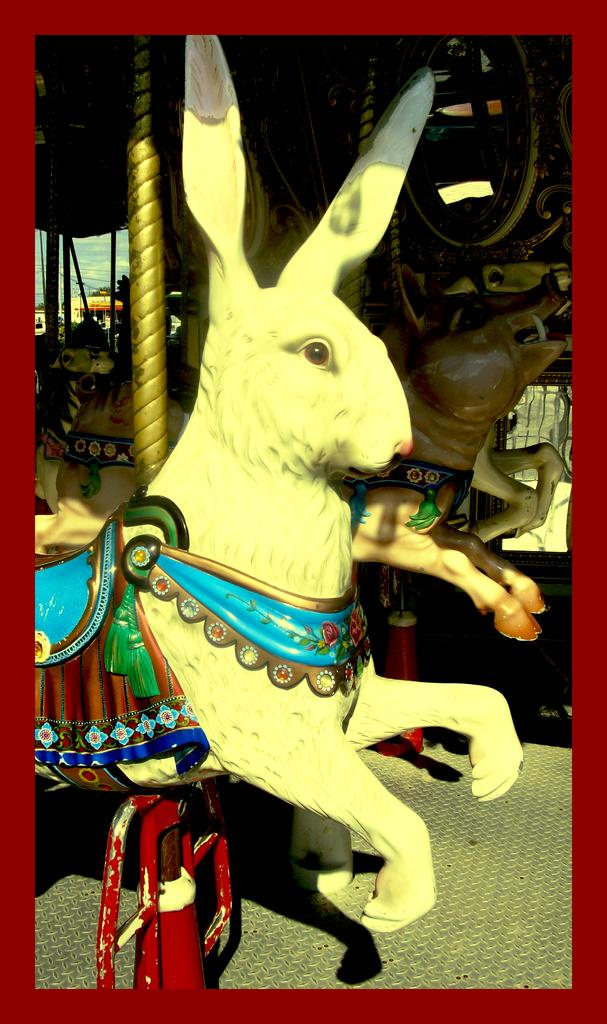What is the shape of the main object in the image? There is an object in the shape of a rabbit in the image. Can you describe the second object in the image? There is another object in the shape of an animal at the back side of the image. What type of food is being prepared on the floor in the image? There is no food or floor visible in the image; it only features two objects in the shape of animals. 